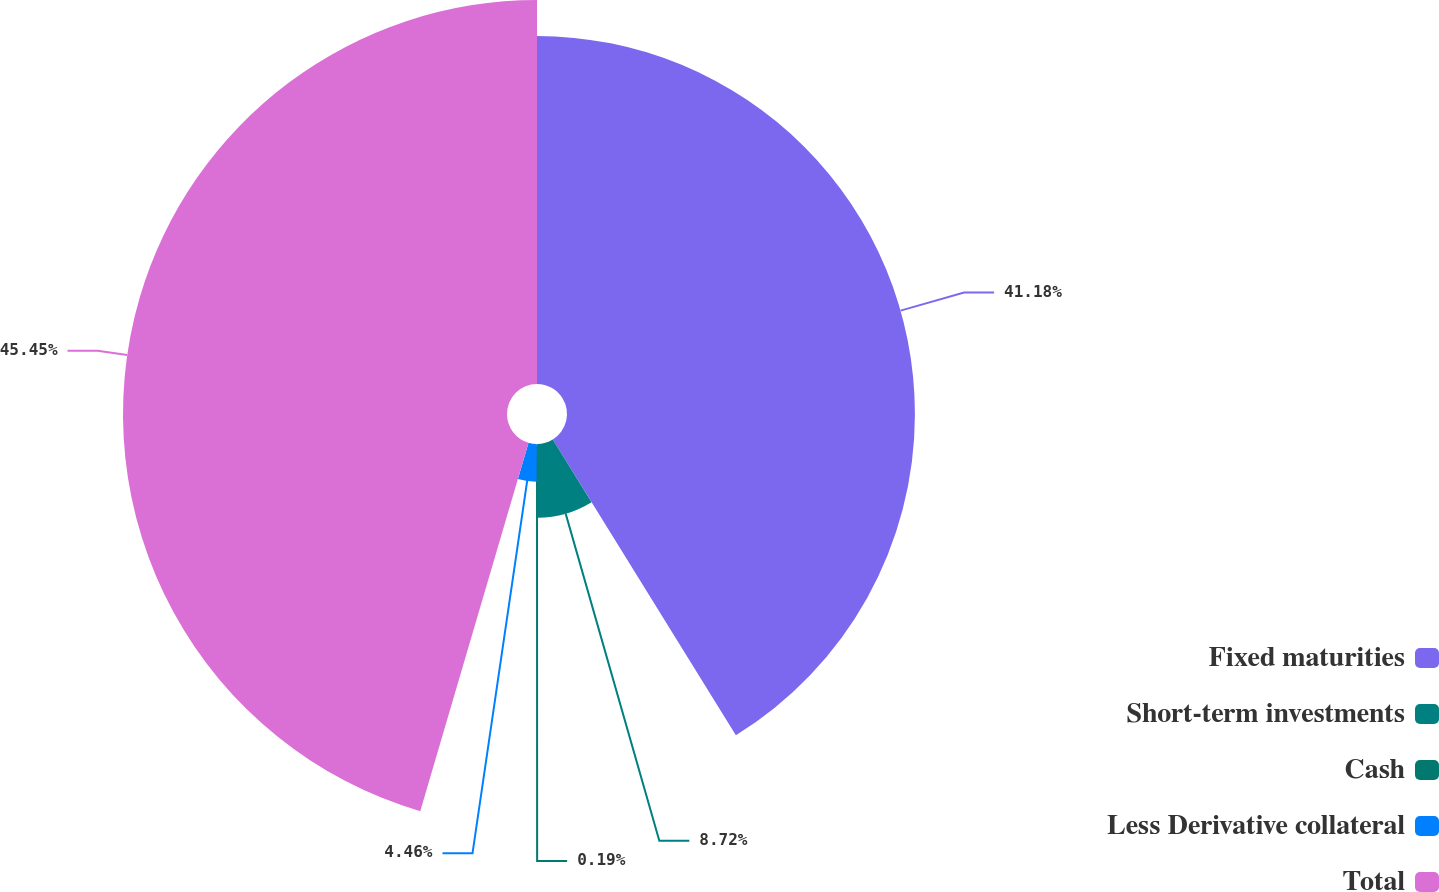Convert chart to OTSL. <chart><loc_0><loc_0><loc_500><loc_500><pie_chart><fcel>Fixed maturities<fcel>Short-term investments<fcel>Cash<fcel>Less Derivative collateral<fcel>Total<nl><fcel>41.18%<fcel>8.72%<fcel>0.19%<fcel>4.46%<fcel>45.45%<nl></chart> 